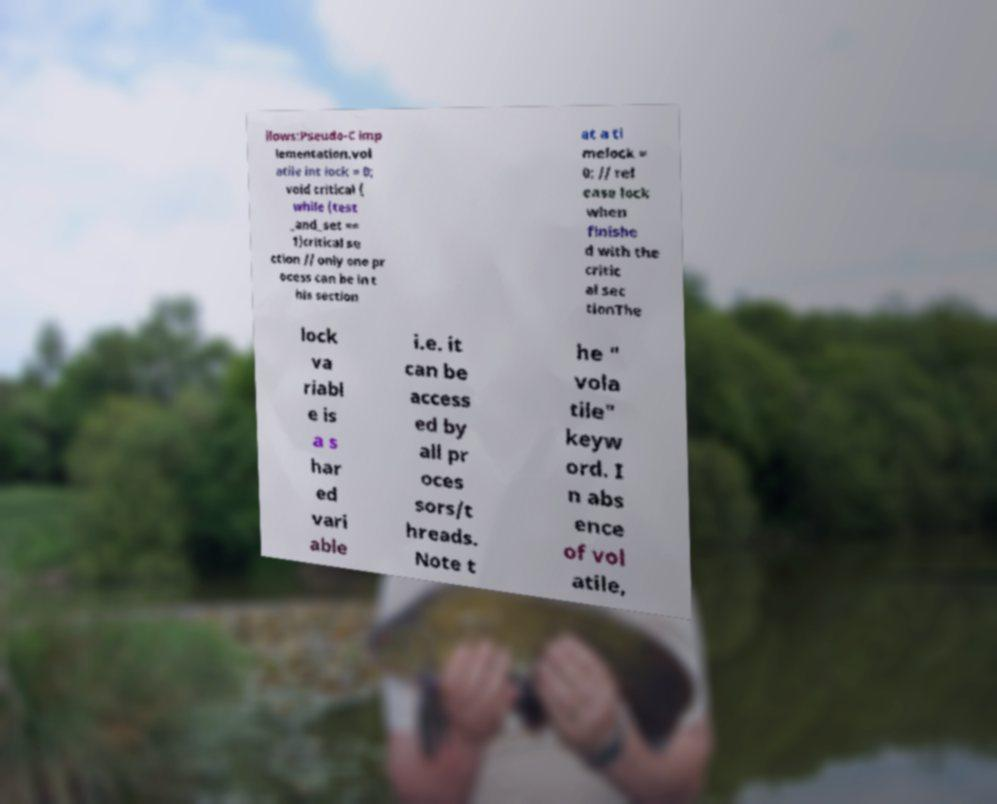What messages or text are displayed in this image? I need them in a readable, typed format. llows:Pseudo-C imp lementation.vol atile int lock = 0; void critical { while (test _and_set == 1)critical se ction // only one pr ocess can be in t his section at a ti melock = 0; // rel ease lock when finishe d with the critic al sec tionThe lock va riabl e is a s har ed vari able i.e. it can be access ed by all pr oces sors/t hreads. Note t he " vola tile" keyw ord. I n abs ence of vol atile, 